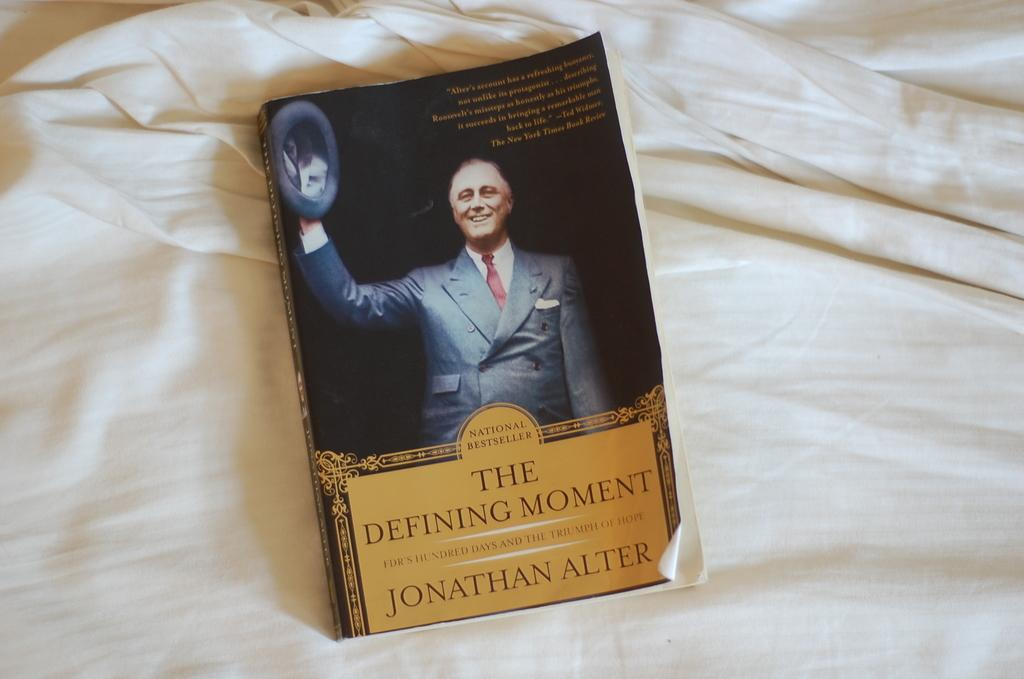<image>
Share a concise interpretation of the image provided. A book titled The Defining Moment by Johnathan Alter. 